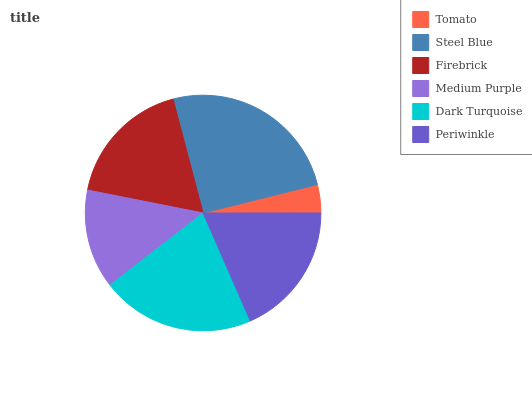Is Tomato the minimum?
Answer yes or no. Yes. Is Steel Blue the maximum?
Answer yes or no. Yes. Is Firebrick the minimum?
Answer yes or no. No. Is Firebrick the maximum?
Answer yes or no. No. Is Steel Blue greater than Firebrick?
Answer yes or no. Yes. Is Firebrick less than Steel Blue?
Answer yes or no. Yes. Is Firebrick greater than Steel Blue?
Answer yes or no. No. Is Steel Blue less than Firebrick?
Answer yes or no. No. Is Periwinkle the high median?
Answer yes or no. Yes. Is Firebrick the low median?
Answer yes or no. Yes. Is Medium Purple the high median?
Answer yes or no. No. Is Steel Blue the low median?
Answer yes or no. No. 